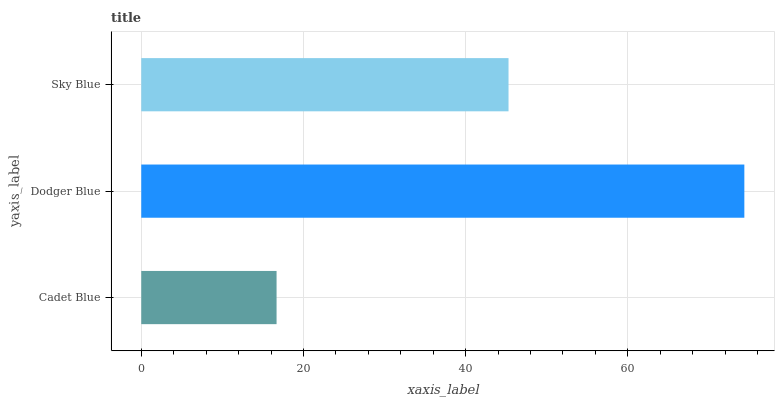Is Cadet Blue the minimum?
Answer yes or no. Yes. Is Dodger Blue the maximum?
Answer yes or no. Yes. Is Sky Blue the minimum?
Answer yes or no. No. Is Sky Blue the maximum?
Answer yes or no. No. Is Dodger Blue greater than Sky Blue?
Answer yes or no. Yes. Is Sky Blue less than Dodger Blue?
Answer yes or no. Yes. Is Sky Blue greater than Dodger Blue?
Answer yes or no. No. Is Dodger Blue less than Sky Blue?
Answer yes or no. No. Is Sky Blue the high median?
Answer yes or no. Yes. Is Sky Blue the low median?
Answer yes or no. Yes. Is Cadet Blue the high median?
Answer yes or no. No. Is Dodger Blue the low median?
Answer yes or no. No. 